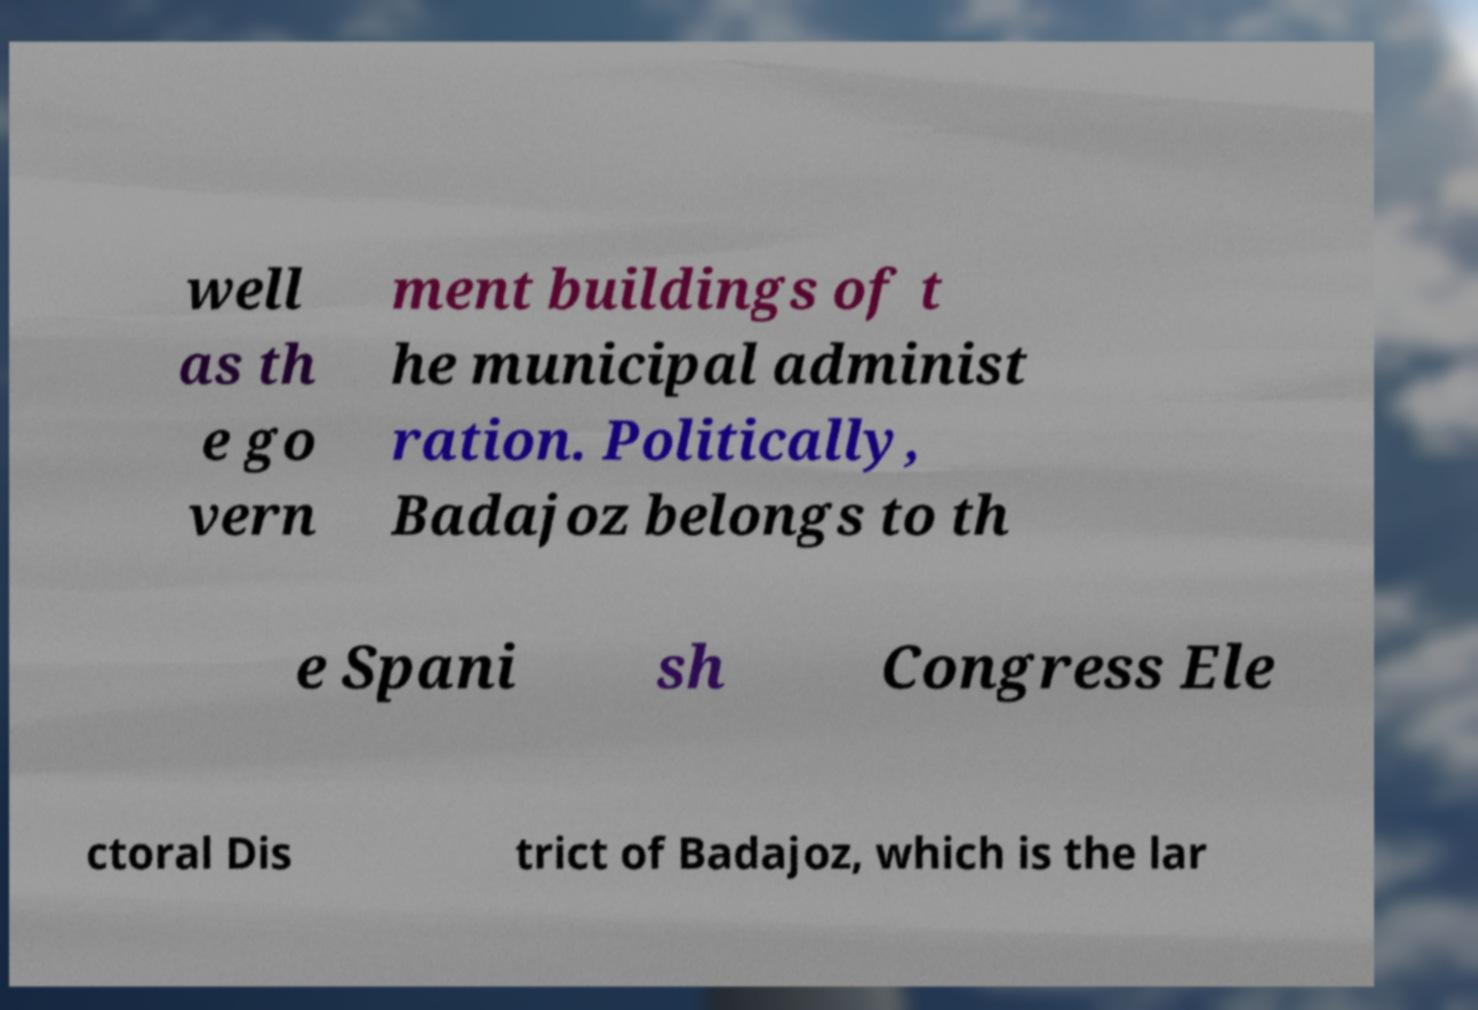What messages or text are displayed in this image? I need them in a readable, typed format. well as th e go vern ment buildings of t he municipal administ ration. Politically, Badajoz belongs to th e Spani sh Congress Ele ctoral Dis trict of Badajoz, which is the lar 